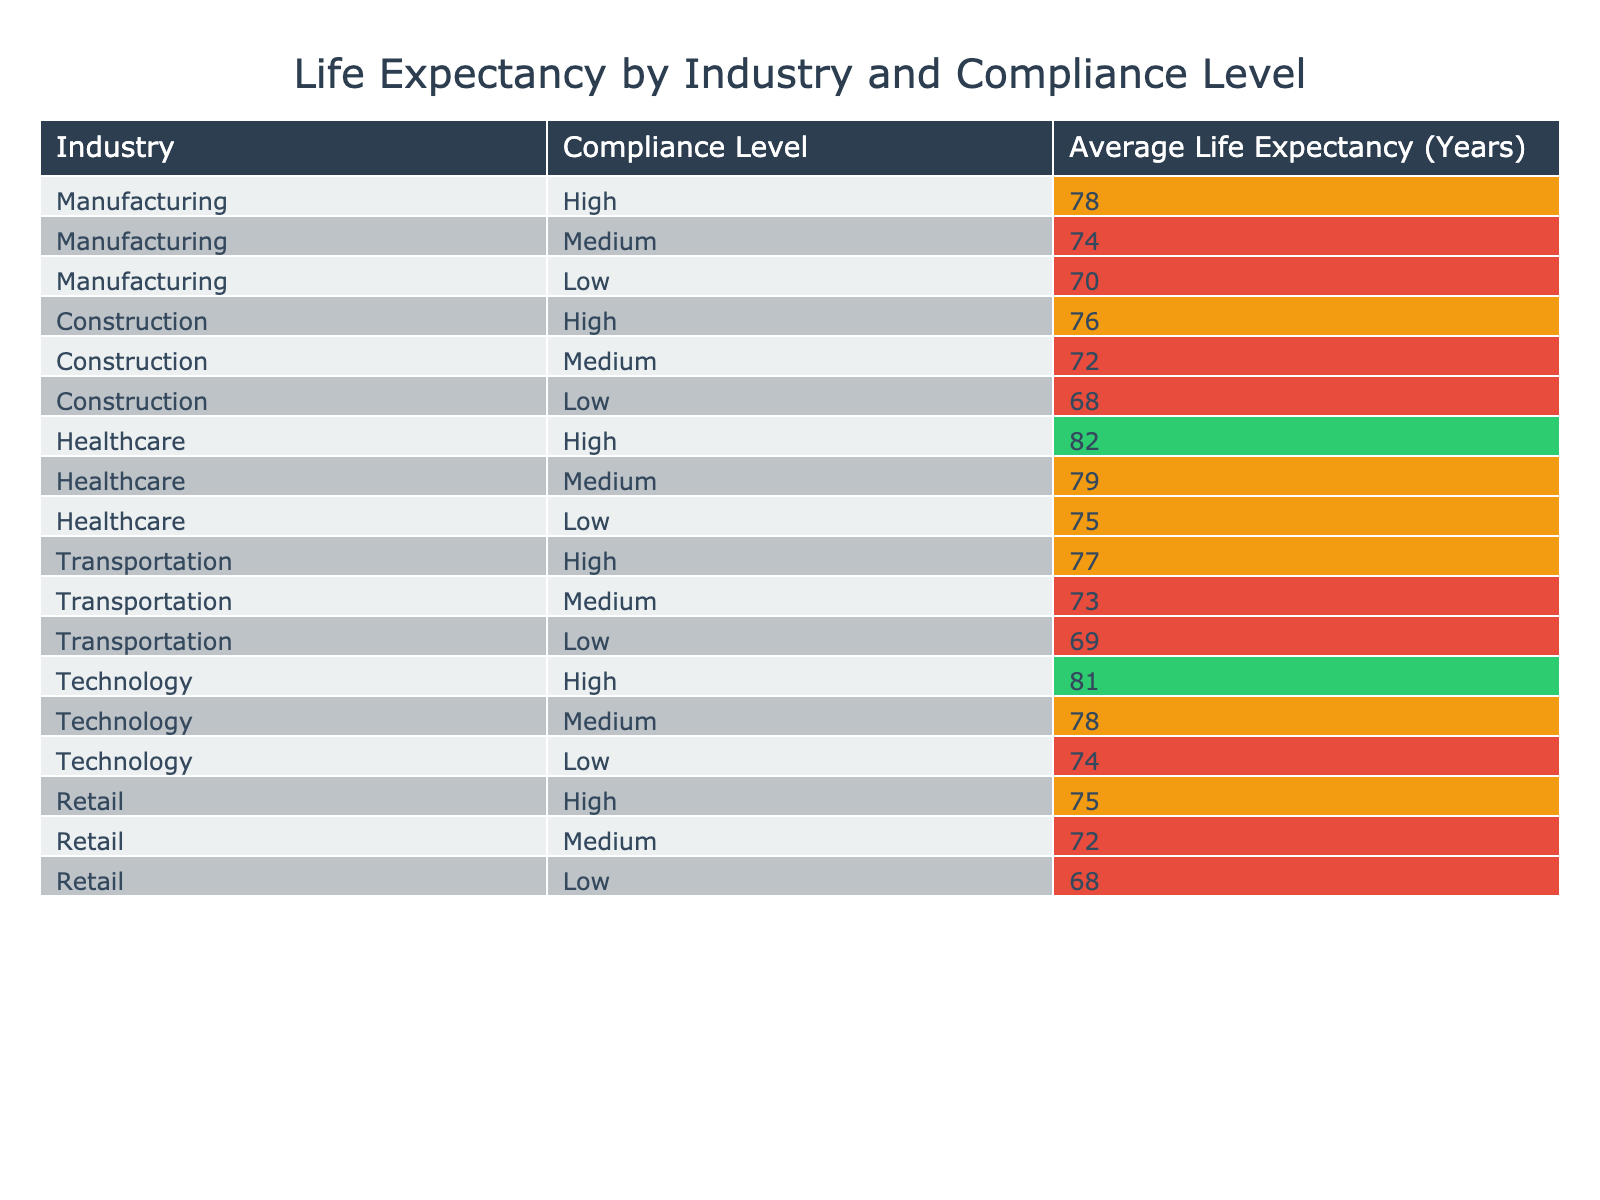What is the average life expectancy for employees in the healthcare industry? From the table, the average life expectancy for the healthcare industry at different compliance levels is 82, 79, and 75 years. To find the average, we sum these values: 82 + 79 + 75 = 236. Since there are three data points, we divide by 3: 236 / 3 = 78.67 (or approximately 79 when rounded).
Answer: 79 Which industry has the highest average life expectancy for employees? Looking at the average life expectancies in each industry, healthcare has the highest value at 82 years. None of the other industries exceed this figure.
Answer: Healthcare Is the average life expectancy in the manufacturing industry lower than in the transportation industry? The average life expectancies for manufacturing are 78, 74, and 70 years, which average to 74 years. For transportation, they are 77, 73, and 69 years, averaging 73. Since 74 is greater than 73, the statement is false.
Answer: No What is the difference in average life expectancy between high compliance levels in technology and healthcare? The average life expectancy for technology at high compliance is 81 years, while for healthcare it is 82 years. To find the difference, we calculate 82 - 81 = 1 year.
Answer: 1 Are there any industries where a low compliance level corresponds to an average life expectancy above 70 years? From the data, the industries with low compliance levels and their respective life expectancies are as follows: manufacturing (70), construction (68), healthcare (75), transportation (69), technology (74), and retail (68). Only healthcare with 75 years exceeds 70 years in low compliance. Therefore, the statement is partially true.
Answer: Yes What is the average life expectancy for all industries at high compliance levels? The high compliance life expectancies are 78 (manufacturing), 76 (construction), 82 (healthcare), 77 (transportation), and 81 (technology). Summing these gives 78 + 76 + 82 + 77 + 81 = 394. There are five data points, so we divide: 394 / 5 = 78.8, or approximately 79 when rounded.
Answer: 79 What percentage of industries have a medium compliance level with an average life expectancy below 75 years? The medium compliance levels for industries are: manufacturing (74), construction (72), healthcare (79), transportation (73), technology (78), and retail (72). The only industries with average life expectancy below 75 are manufacturing, construction, and transportation—totaling 3. There are six industries, so the percentage is (3/6) * 100 = 50%.
Answer: 50% What is the lowest average life expectancy recorded in the table? Reviewing the life expectancies listed, the lowest recorded is 68 years, which appears in the construction and retail industries at low compliance levels.
Answer: 68 